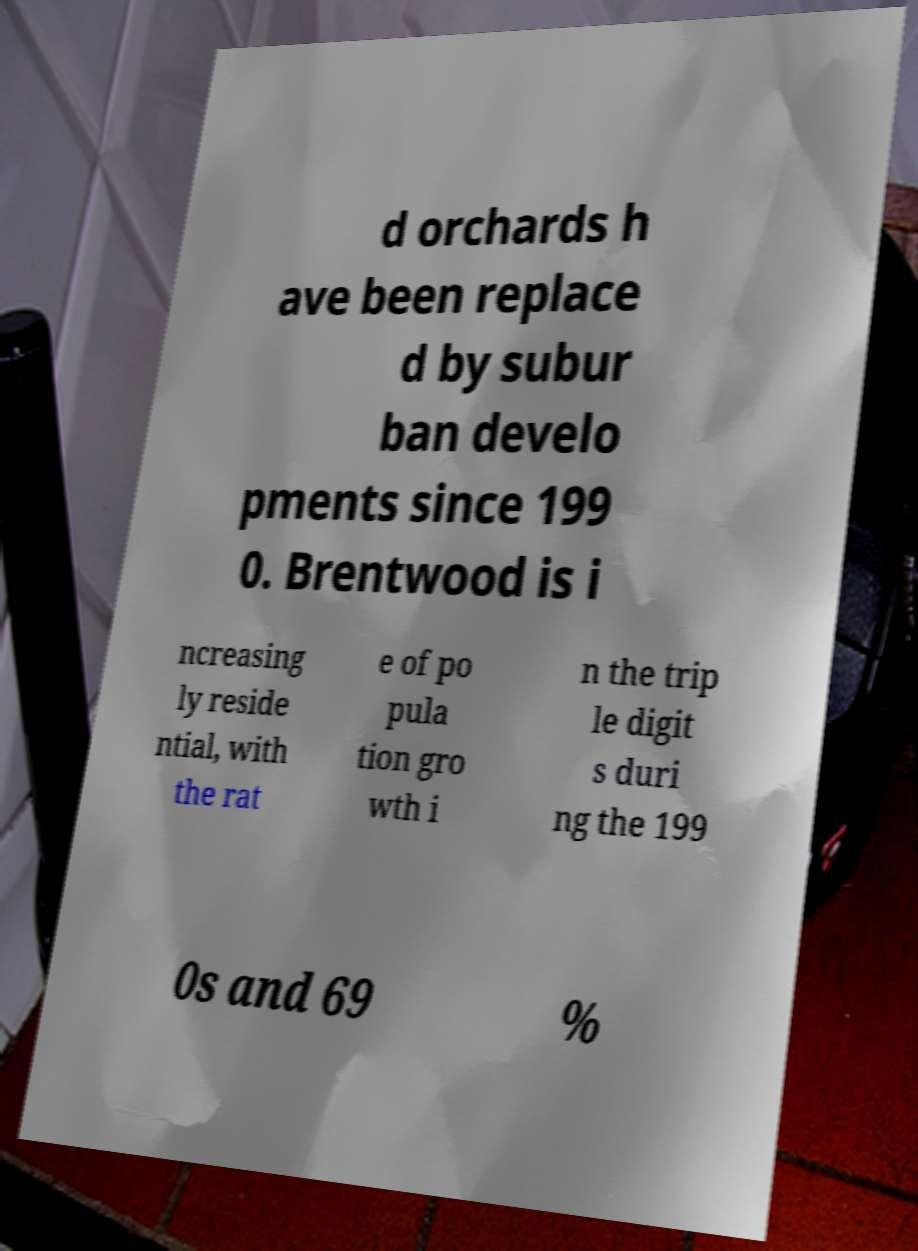There's text embedded in this image that I need extracted. Can you transcribe it verbatim? d orchards h ave been replace d by subur ban develo pments since 199 0. Brentwood is i ncreasing ly reside ntial, with the rat e of po pula tion gro wth i n the trip le digit s duri ng the 199 0s and 69 % 